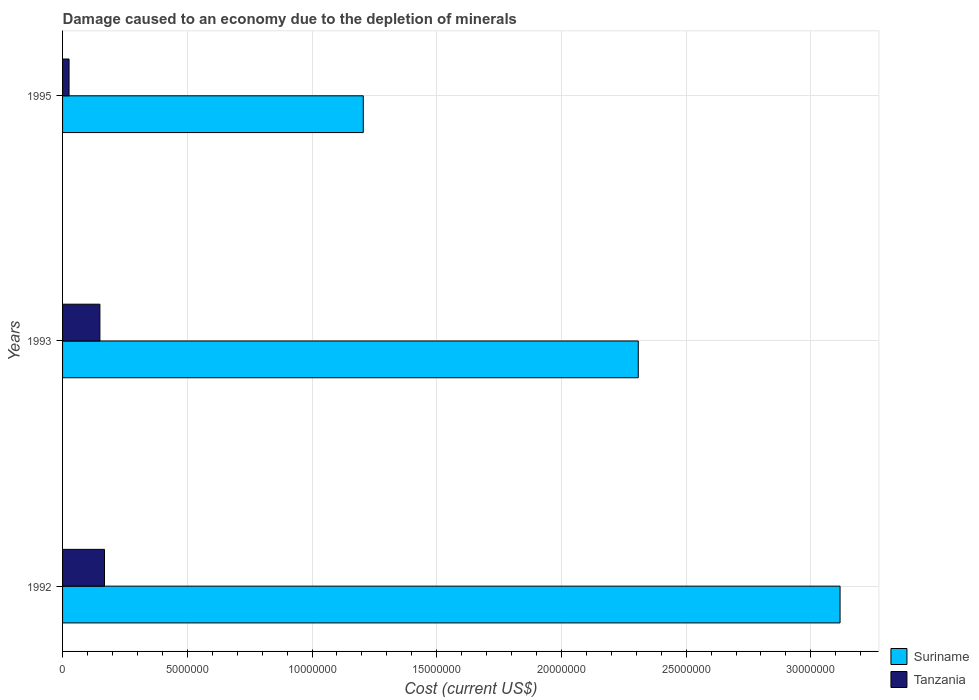How many different coloured bars are there?
Provide a succinct answer. 2. How many bars are there on the 2nd tick from the bottom?
Your response must be concise. 2. What is the cost of damage caused due to the depletion of minerals in Suriname in 1995?
Keep it short and to the point. 1.21e+07. Across all years, what is the maximum cost of damage caused due to the depletion of minerals in Suriname?
Make the answer very short. 3.12e+07. Across all years, what is the minimum cost of damage caused due to the depletion of minerals in Tanzania?
Keep it short and to the point. 2.60e+05. What is the total cost of damage caused due to the depletion of minerals in Suriname in the graph?
Your answer should be compact. 6.63e+07. What is the difference between the cost of damage caused due to the depletion of minerals in Tanzania in 1992 and that in 1995?
Your answer should be compact. 1.42e+06. What is the difference between the cost of damage caused due to the depletion of minerals in Suriname in 1993 and the cost of damage caused due to the depletion of minerals in Tanzania in 1992?
Give a very brief answer. 2.14e+07. What is the average cost of damage caused due to the depletion of minerals in Suriname per year?
Make the answer very short. 2.21e+07. In the year 1993, what is the difference between the cost of damage caused due to the depletion of minerals in Tanzania and cost of damage caused due to the depletion of minerals in Suriname?
Provide a succinct answer. -2.16e+07. What is the ratio of the cost of damage caused due to the depletion of minerals in Suriname in 1992 to that in 1995?
Offer a very short reply. 2.59. Is the difference between the cost of damage caused due to the depletion of minerals in Tanzania in 1992 and 1993 greater than the difference between the cost of damage caused due to the depletion of minerals in Suriname in 1992 and 1993?
Make the answer very short. No. What is the difference between the highest and the second highest cost of damage caused due to the depletion of minerals in Suriname?
Keep it short and to the point. 8.09e+06. What is the difference between the highest and the lowest cost of damage caused due to the depletion of minerals in Suriname?
Ensure brevity in your answer.  1.91e+07. What does the 2nd bar from the top in 1992 represents?
Keep it short and to the point. Suriname. What does the 2nd bar from the bottom in 1995 represents?
Your answer should be compact. Tanzania. Are all the bars in the graph horizontal?
Offer a very short reply. Yes. What is the difference between two consecutive major ticks on the X-axis?
Your response must be concise. 5.00e+06. Does the graph contain grids?
Offer a very short reply. Yes. How many legend labels are there?
Ensure brevity in your answer.  2. What is the title of the graph?
Your response must be concise. Damage caused to an economy due to the depletion of minerals. Does "Congo (Republic)" appear as one of the legend labels in the graph?
Your answer should be very brief. No. What is the label or title of the X-axis?
Your answer should be compact. Cost (current US$). What is the Cost (current US$) in Suriname in 1992?
Your response must be concise. 3.12e+07. What is the Cost (current US$) of Tanzania in 1992?
Offer a terse response. 1.68e+06. What is the Cost (current US$) of Suriname in 1993?
Make the answer very short. 2.31e+07. What is the Cost (current US$) of Tanzania in 1993?
Offer a very short reply. 1.50e+06. What is the Cost (current US$) of Suriname in 1995?
Provide a short and direct response. 1.21e+07. What is the Cost (current US$) of Tanzania in 1995?
Provide a short and direct response. 2.60e+05. Across all years, what is the maximum Cost (current US$) in Suriname?
Your answer should be very brief. 3.12e+07. Across all years, what is the maximum Cost (current US$) in Tanzania?
Ensure brevity in your answer.  1.68e+06. Across all years, what is the minimum Cost (current US$) in Suriname?
Give a very brief answer. 1.21e+07. Across all years, what is the minimum Cost (current US$) in Tanzania?
Offer a very short reply. 2.60e+05. What is the total Cost (current US$) in Suriname in the graph?
Your response must be concise. 6.63e+07. What is the total Cost (current US$) of Tanzania in the graph?
Offer a very short reply. 3.44e+06. What is the difference between the Cost (current US$) of Suriname in 1992 and that in 1993?
Offer a terse response. 8.09e+06. What is the difference between the Cost (current US$) of Tanzania in 1992 and that in 1993?
Keep it short and to the point. 1.84e+05. What is the difference between the Cost (current US$) in Suriname in 1992 and that in 1995?
Your answer should be very brief. 1.91e+07. What is the difference between the Cost (current US$) of Tanzania in 1992 and that in 1995?
Ensure brevity in your answer.  1.42e+06. What is the difference between the Cost (current US$) of Suriname in 1993 and that in 1995?
Offer a terse response. 1.10e+07. What is the difference between the Cost (current US$) of Tanzania in 1993 and that in 1995?
Your response must be concise. 1.24e+06. What is the difference between the Cost (current US$) in Suriname in 1992 and the Cost (current US$) in Tanzania in 1993?
Give a very brief answer. 2.97e+07. What is the difference between the Cost (current US$) in Suriname in 1992 and the Cost (current US$) in Tanzania in 1995?
Offer a terse response. 3.09e+07. What is the difference between the Cost (current US$) in Suriname in 1993 and the Cost (current US$) in Tanzania in 1995?
Your response must be concise. 2.28e+07. What is the average Cost (current US$) of Suriname per year?
Provide a short and direct response. 2.21e+07. What is the average Cost (current US$) of Tanzania per year?
Your answer should be compact. 1.15e+06. In the year 1992, what is the difference between the Cost (current US$) in Suriname and Cost (current US$) in Tanzania?
Your response must be concise. 2.95e+07. In the year 1993, what is the difference between the Cost (current US$) of Suriname and Cost (current US$) of Tanzania?
Your response must be concise. 2.16e+07. In the year 1995, what is the difference between the Cost (current US$) in Suriname and Cost (current US$) in Tanzania?
Provide a succinct answer. 1.18e+07. What is the ratio of the Cost (current US$) of Suriname in 1992 to that in 1993?
Provide a succinct answer. 1.35. What is the ratio of the Cost (current US$) of Tanzania in 1992 to that in 1993?
Provide a succinct answer. 1.12. What is the ratio of the Cost (current US$) of Suriname in 1992 to that in 1995?
Provide a short and direct response. 2.59. What is the ratio of the Cost (current US$) of Tanzania in 1992 to that in 1995?
Give a very brief answer. 6.46. What is the ratio of the Cost (current US$) of Suriname in 1993 to that in 1995?
Your answer should be compact. 1.91. What is the ratio of the Cost (current US$) of Tanzania in 1993 to that in 1995?
Provide a short and direct response. 5.75. What is the difference between the highest and the second highest Cost (current US$) in Suriname?
Give a very brief answer. 8.09e+06. What is the difference between the highest and the second highest Cost (current US$) of Tanzania?
Your answer should be compact. 1.84e+05. What is the difference between the highest and the lowest Cost (current US$) of Suriname?
Provide a short and direct response. 1.91e+07. What is the difference between the highest and the lowest Cost (current US$) in Tanzania?
Give a very brief answer. 1.42e+06. 